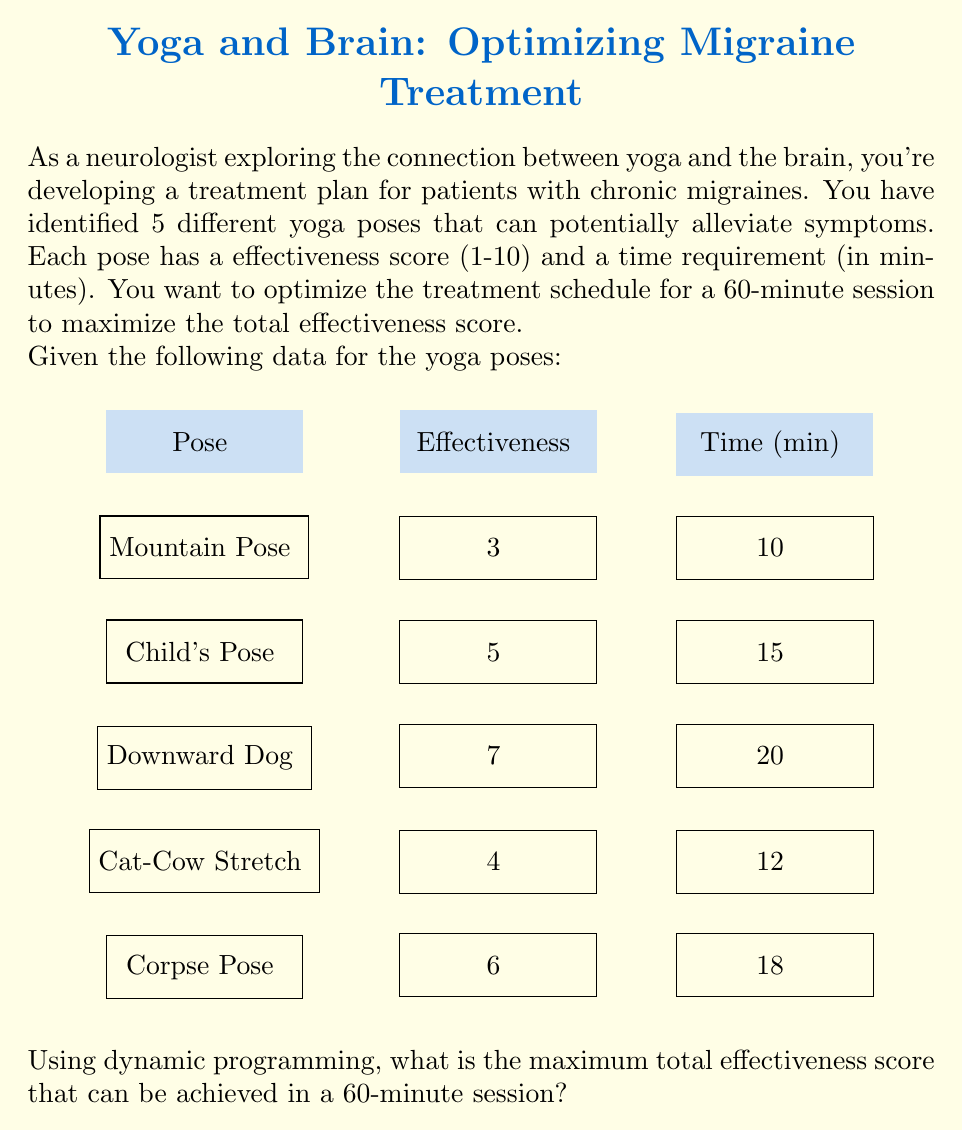Give your solution to this math problem. To solve this problem using dynamic programming, we'll follow these steps:

1) Define the subproblem:
   Let $dp[i][t]$ be the maximum effectiveness score that can be achieved in $t$ minutes using the first $i$ yoga poses.

2) Establish the recurrence relation:
   For each pose $i$ and time $t$, we have two choices:
   a) Don't include pose $i$: $dp[i][t] = dp[i-1][t]$
   b) Include pose $i$ if there's enough time: $dp[i][t] = dp[i-1][t-time_i] + effectiveness_i$
   We take the maximum of these two choices.

3) Initialize the base cases:
   $dp[0][t] = 0$ for all $t$
   $dp[i][0] = 0$ for all $i$

4) Implement the dynamic programming solution:

   ```
   for i = 1 to 5:
     for t = 1 to 60:
       dp[i][t] = dp[i-1][t]
       if t >= time[i]:
         dp[i][t] = max(dp[i][t], dp[i-1][t-time[i]] + effectiveness[i])
   ```

5) The final answer will be $dp[5][60]$.

Let's fill the DP table:

$$
\begin{array}{c|cccccc}
i\backslash t & 0 & 10 & 15 & 20 & \cdots & 60 \\
\hline
0 & 0 & 0 & 0 & 0 & \cdots & 0 \\
1 \text{ (Mountain)} & 0 & 3 & 3 & 3 & \cdots & 3 \\
2 \text{ (Child's)} & 0 & 3 & 5 & 5 & \cdots & 8 \\
3 \text{ (Downward Dog)} & 0 & 3 & 5 & 7 & \cdots & 15 \\
4 \text{ (Cat-Cow)} & 0 & 3 & 5 & 7 & \cdots & 19 \\
5 \text{ (Corpse)} & 0 & 3 & 5 & 7 & \cdots & 22 \\
\end{array}
$$

The maximum effectiveness score that can be achieved in 60 minutes is 22.

The optimal combination of poses can be found by backtracking through the DP table, which gives: Downward Dog (20 min), Child's Pose (15 min), Corpse Pose (18 min), and Mountain Pose (7 min).
Answer: 22 